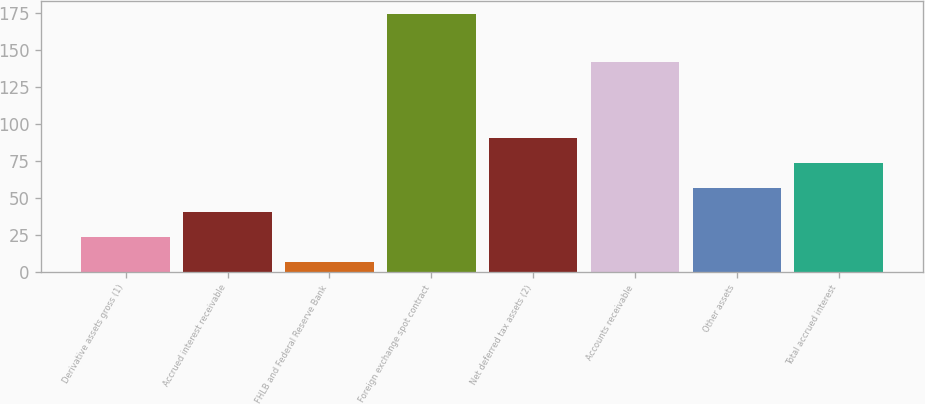Convert chart. <chart><loc_0><loc_0><loc_500><loc_500><bar_chart><fcel>Derivative assets gross (1)<fcel>Accrued interest receivable<fcel>FHLB and Federal Reserve Bank<fcel>Foreign exchange spot contract<fcel>Net deferred tax assets (2)<fcel>Accounts receivable<fcel>Other assets<fcel>Total accrued interest<nl><fcel>23.33<fcel>40.16<fcel>6.5<fcel>174.8<fcel>90.65<fcel>142.2<fcel>56.99<fcel>73.82<nl></chart> 